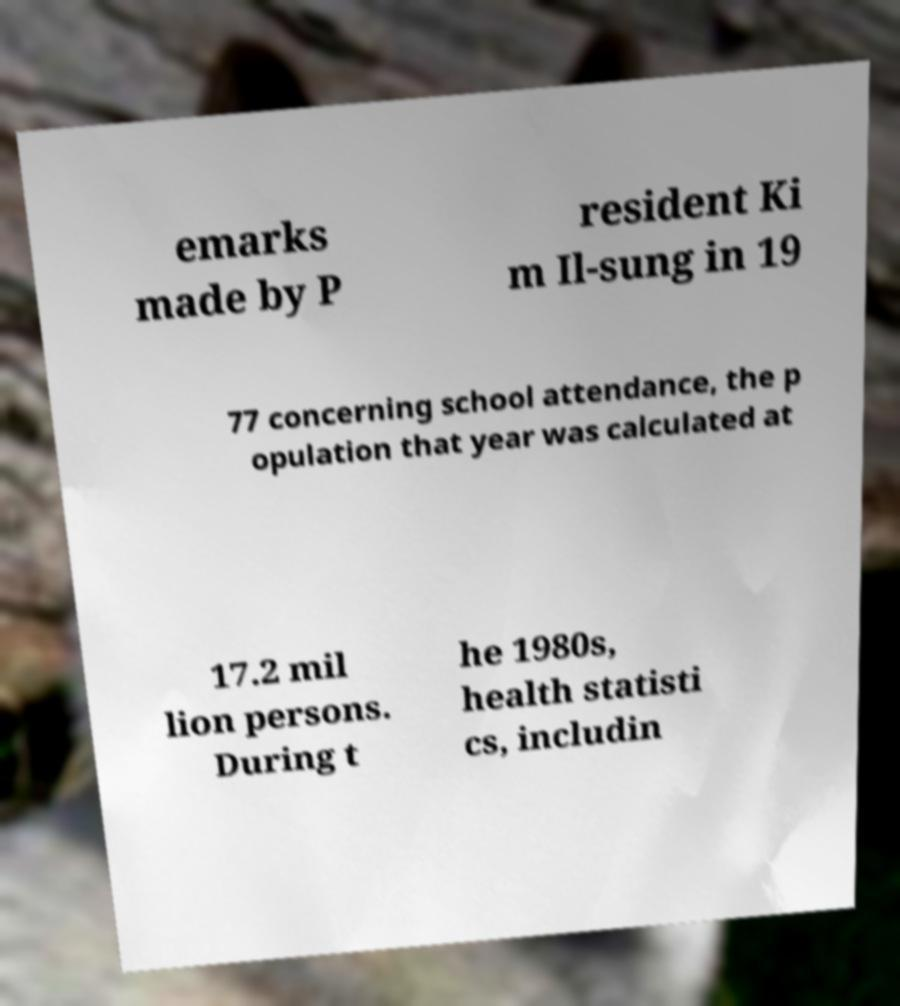Can you read and provide the text displayed in the image?This photo seems to have some interesting text. Can you extract and type it out for me? emarks made by P resident Ki m Il-sung in 19 77 concerning school attendance, the p opulation that year was calculated at 17.2 mil lion persons. During t he 1980s, health statisti cs, includin 